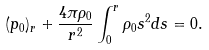Convert formula to latex. <formula><loc_0><loc_0><loc_500><loc_500>( p _ { 0 } ) _ { r } + \frac { 4 \pi \rho _ { 0 } } { r ^ { 2 } } \int _ { 0 } ^ { r } \rho _ { 0 } s ^ { 2 } d s = 0 .</formula> 